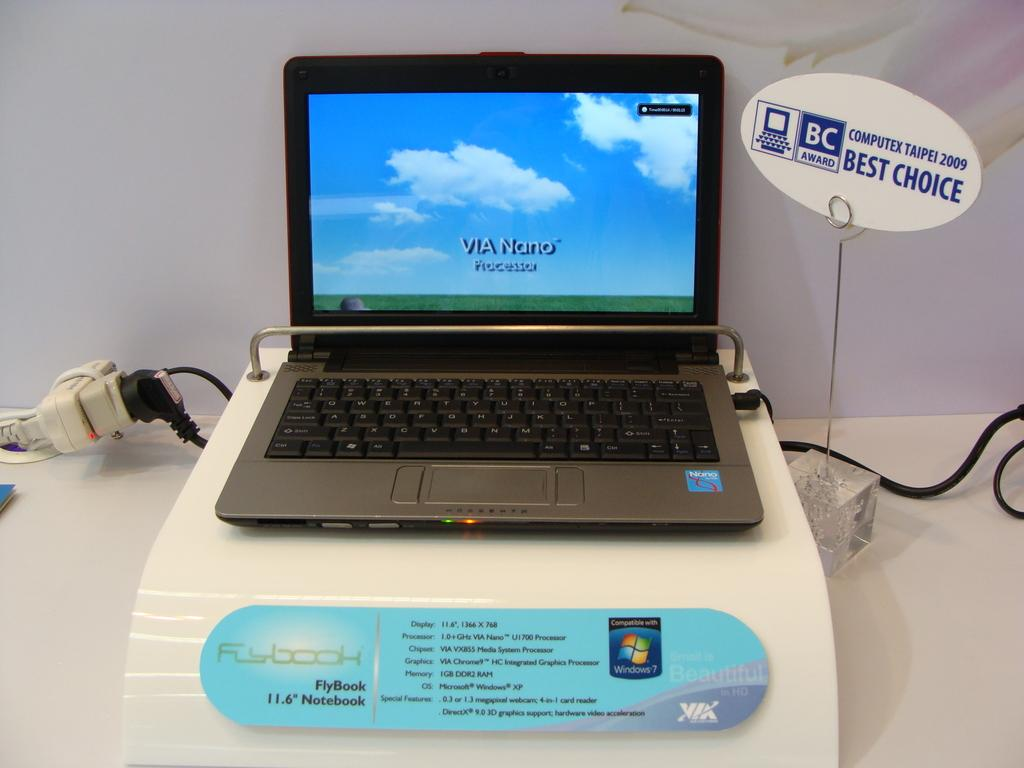<image>
Describe the image concisely. A FlyBook laptop display shows iots processor name on the screen. 